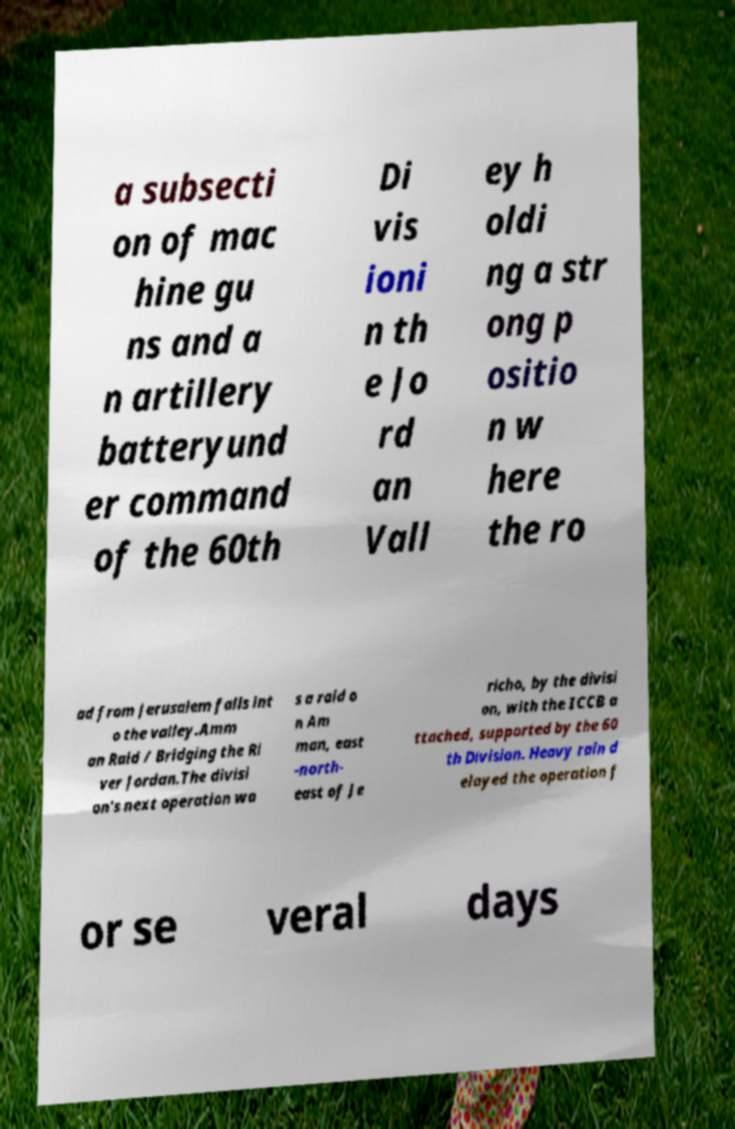Please identify and transcribe the text found in this image. a subsecti on of mac hine gu ns and a n artillery batteryund er command of the 60th Di vis ioni n th e Jo rd an Vall ey h oldi ng a str ong p ositio n w here the ro ad from Jerusalem falls int o the valley.Amm an Raid / Bridging the Ri ver Jordan.The divisi on's next operation wa s a raid o n Am man, east -north- east of Je richo, by the divisi on, with the ICCB a ttached, supported by the 60 th Division. Heavy rain d elayed the operation f or se veral days 